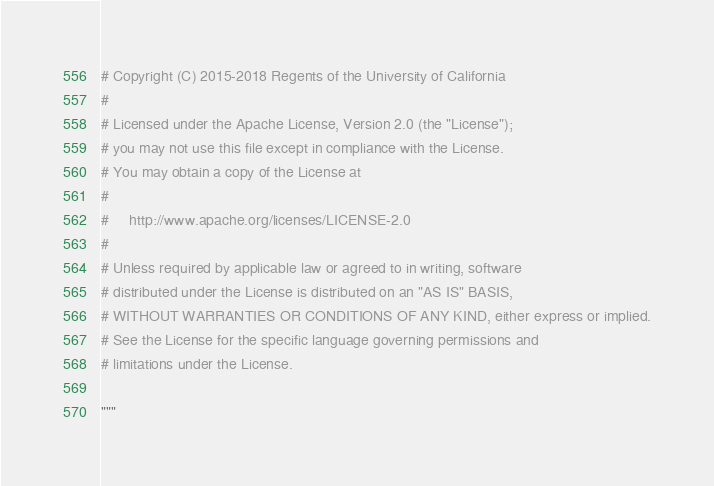<code> <loc_0><loc_0><loc_500><loc_500><_Python_># Copyright (C) 2015-2018 Regents of the University of California
#
# Licensed under the Apache License, Version 2.0 (the "License");
# you may not use this file except in compliance with the License.
# You may obtain a copy of the License at
#
#     http://www.apache.org/licenses/LICENSE-2.0
#
# Unless required by applicable law or agreed to in writing, software
# distributed under the License is distributed on an "AS IS" BASIS,
# WITHOUT WARRANTIES OR CONDITIONS OF ANY KIND, either express or implied.
# See the License for the specific language governing permissions and
# limitations under the License.

"""</code> 